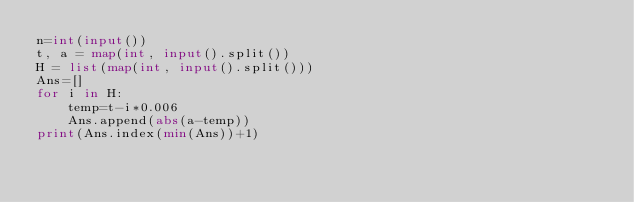<code> <loc_0><loc_0><loc_500><loc_500><_Python_>n=int(input())
t, a = map(int, input().split())
H = list(map(int, input().split()))
Ans=[]
for i in H:
    temp=t-i*0.006
    Ans.append(abs(a-temp))
print(Ans.index(min(Ans))+1)
</code> 